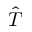Convert formula to latex. <formula><loc_0><loc_0><loc_500><loc_500>\hat { T }</formula> 